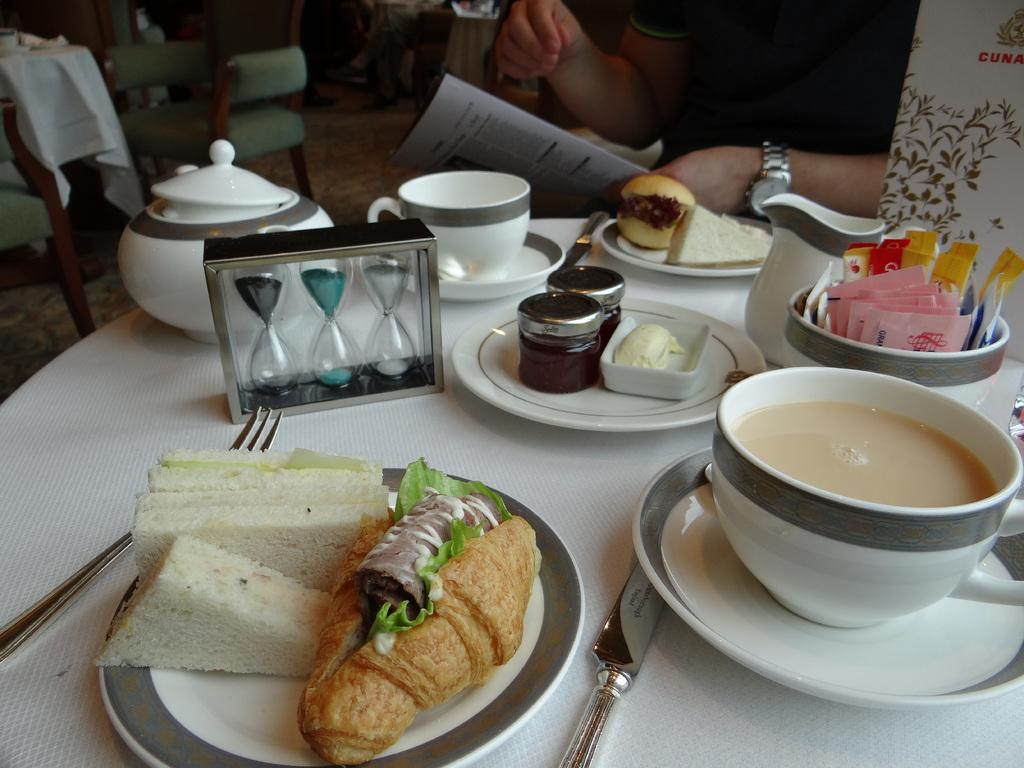What piece of furniture is present in the image? There is a table in the image. What items are placed on the table? There are plates, a cup, a bowl, and food on the table. What can be used for drinking in the image? There is a cup on the table. What is the person in the image sitting on? The chairs are in the background of the image, which suggests that the person might be sitting on one of them. What part of the room is visible in the image? The floor is visible in the image. What type of quartz can be seen in the image? There is no quartz present in the image. Can you describe the snake that is slithering across the table in the image? There is no snake present in the image; it only features a table with various items on it. 